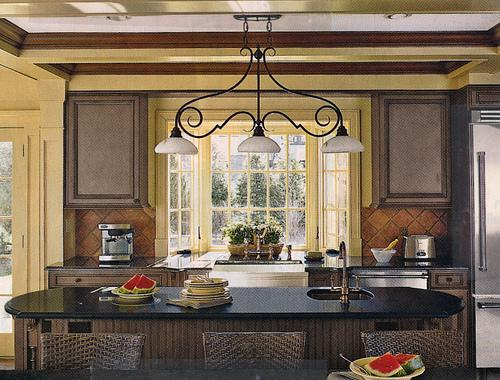In which one of these months do people like to eat this fruit? Please explain your reasoning. july. The people are eating water melon in july because it is the time of year where we pick it 